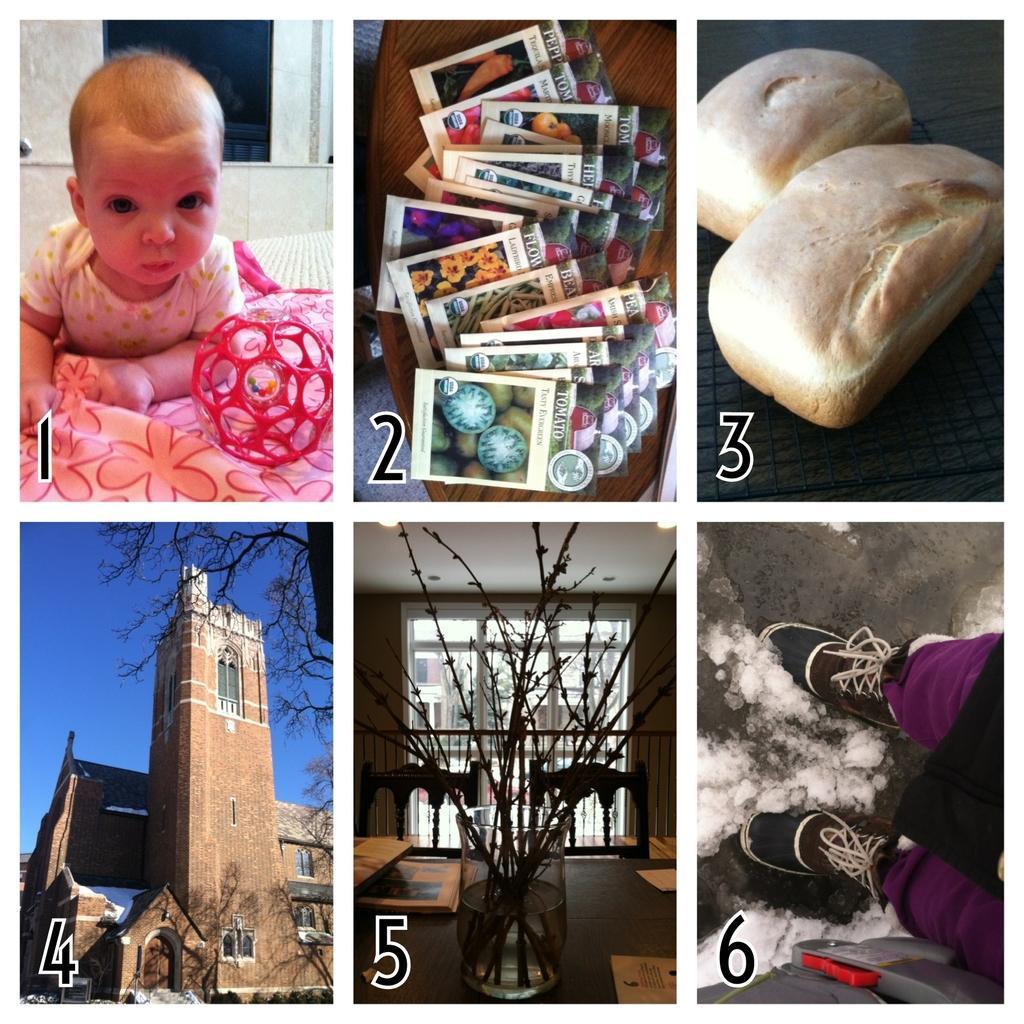Could you give a brief overview of what you see in this image? In the first image there is a lady on the bed with a red ball. Behind him there is a wall with windows. In the second image on the wooden floor there are few cards. In the third image there are buns. In the fourth image there is a building with brick walls, windows and roof. Behind the building there are trees and also there is a sky. In the fifth image to the front of the image there is a glass with water and stems in it. On the table there are few books and papers. Behind the table there is a railing and in front of the railing there is a glass door. In the sixth image there are persons legs with shoes and on the ground there is snow. 